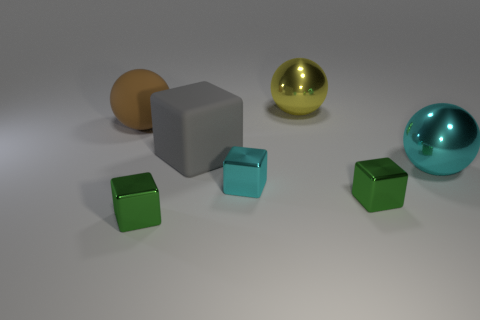What shape is the big object that is both to the right of the gray matte thing and left of the big cyan metal sphere?
Keep it short and to the point. Sphere. How many big gray matte objects have the same shape as the tiny cyan metal thing?
Keep it short and to the point. 1. What size is the yellow sphere that is the same material as the big cyan sphere?
Offer a very short reply. Large. What number of other balls have the same size as the yellow sphere?
Provide a succinct answer. 2. What is the color of the metal block that is behind the small green block on the right side of the tiny cyan cube?
Provide a succinct answer. Cyan. Are there any other balls that have the same color as the rubber sphere?
Offer a terse response. No. What color is the other rubber sphere that is the same size as the yellow ball?
Provide a short and direct response. Brown. Is the material of the small green block that is left of the gray matte block the same as the gray thing?
Offer a terse response. No. Is there a small cyan metallic block that is on the right side of the cyan object on the left side of the large ball in front of the big rubber sphere?
Offer a very short reply. No. Do the tiny green object that is on the left side of the small cyan block and the big brown rubber object have the same shape?
Provide a short and direct response. No. 